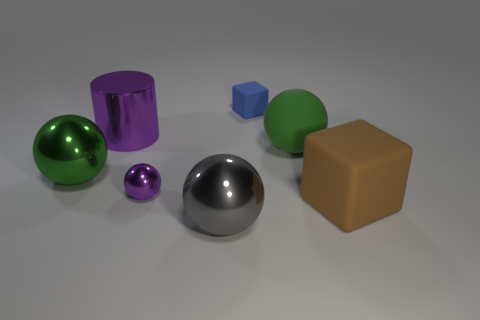Is there a pattern to the arrangement of these objects? The objects seem to be placed in no specific pattern, but they are evenly spaced, allowing each object to be distinct without any overlap on the plane. 